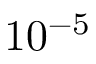Convert formula to latex. <formula><loc_0><loc_0><loc_500><loc_500>1 0 ^ { - 5 }</formula> 